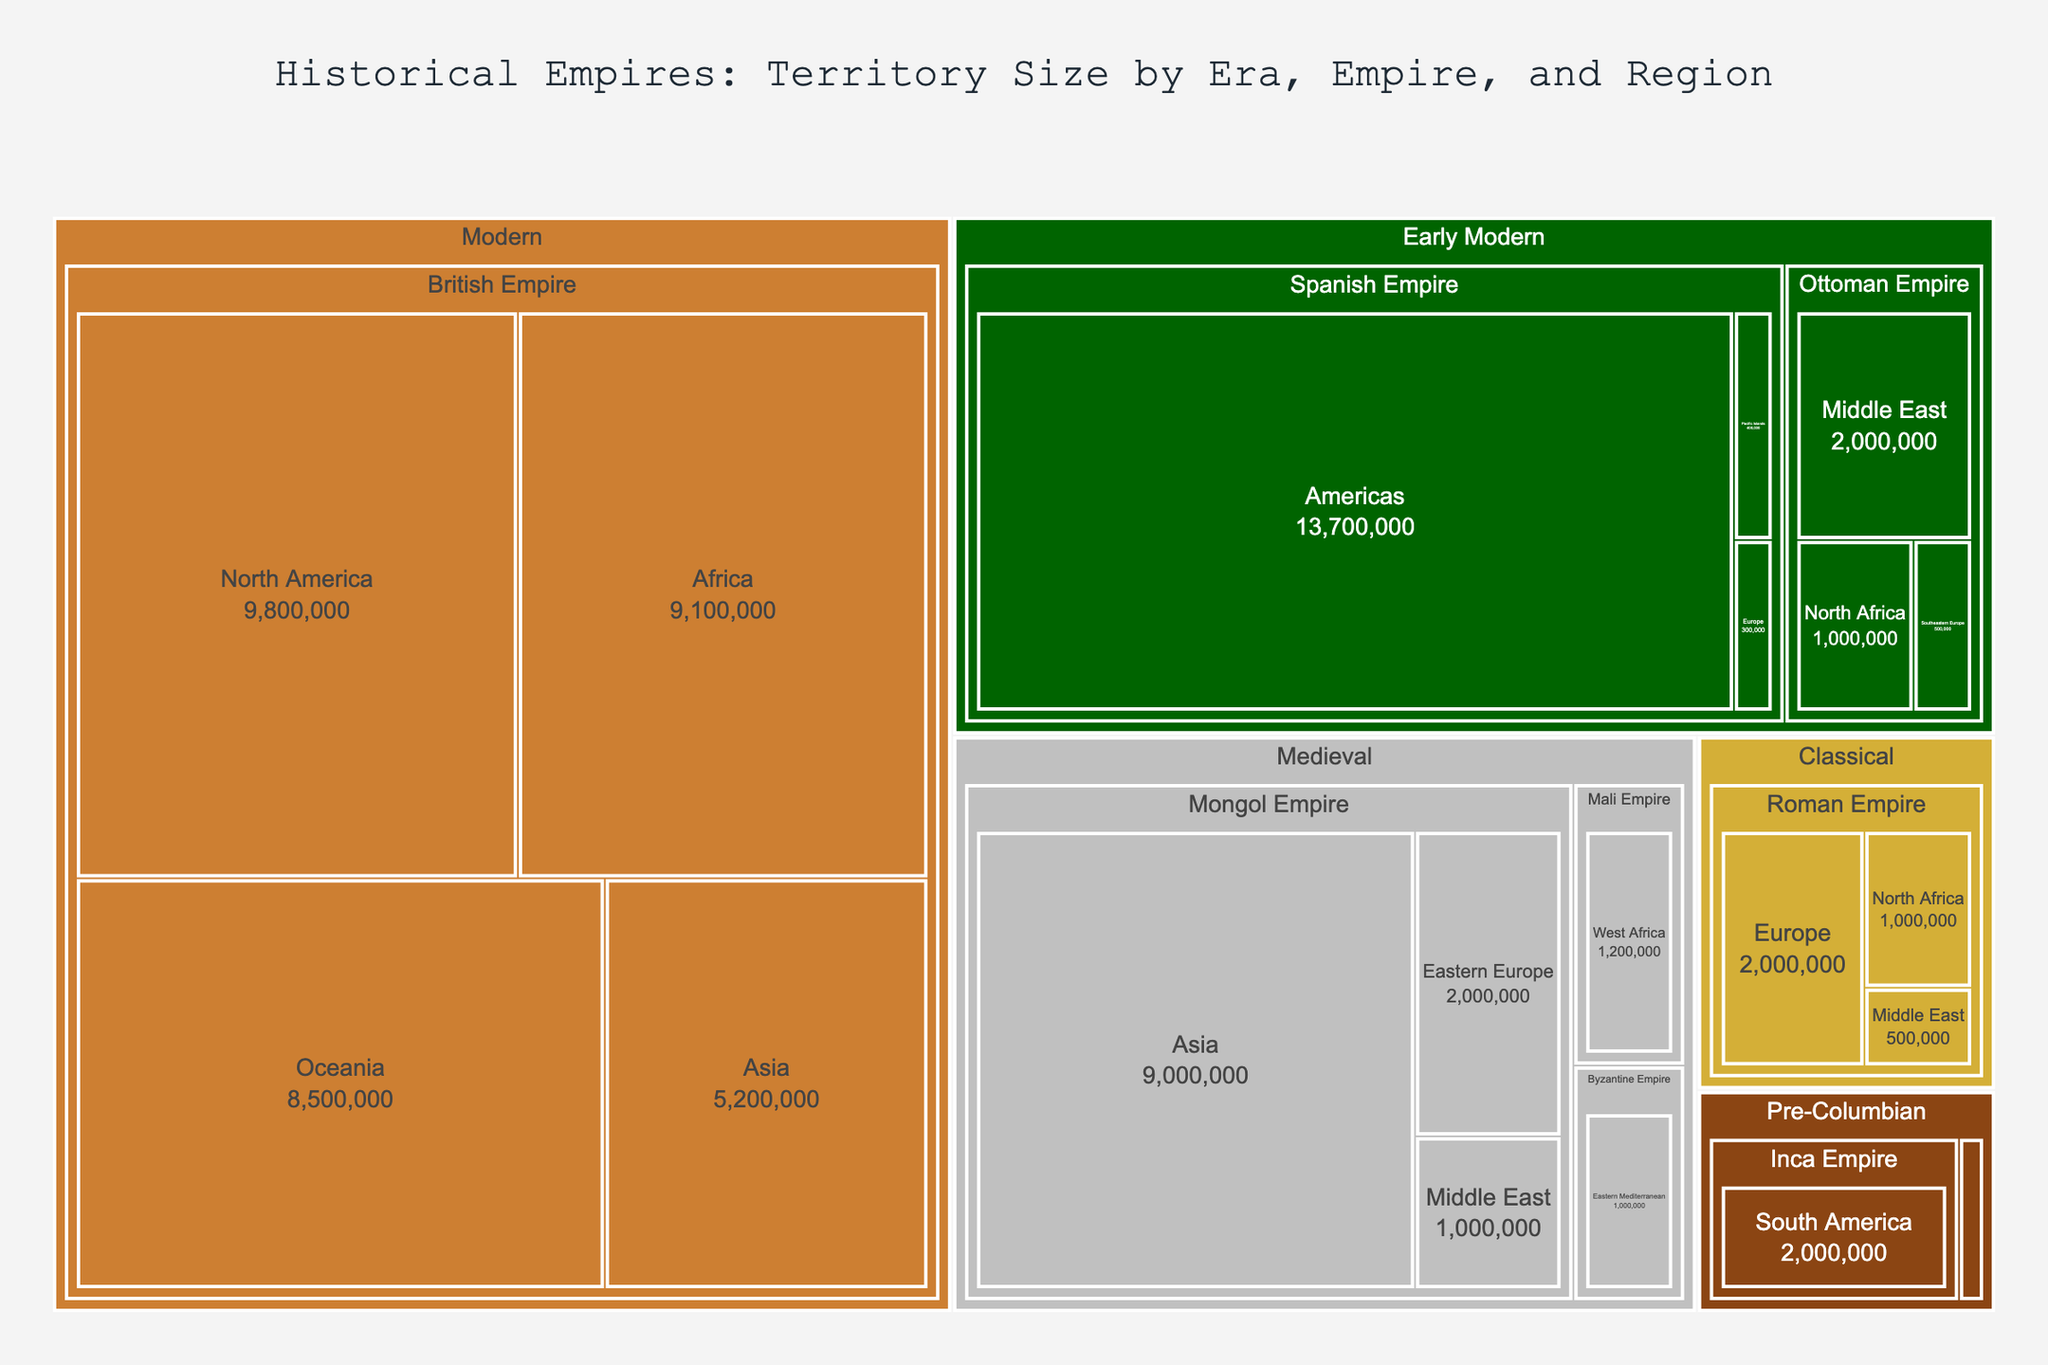What's the title of the Treemap plot? The title of the Treemap plot is usually displayed prominently at the top of the figure. In this case, it is specified in the data that the title is "Historical Empires: Territory Size by Era, Empire, and Region".
Answer: Historical Empires: Territory Size by Era, Empire, and Region Which color represents the Medieval era in the Treemap? The figure uses distinct colors for different eras. According to the data, the Medieval era is represented by the color silver.
Answer: Silver What is the total territory size of the Mongol Empire across all regions? The Mongol Empire has territory sizes of 9,000,000 (Asia), 2,000,000 (Eastern Europe), and 1,000,000 (Middle East). Adding these up, 9,000,000 + 2,000,000 + 1,000,000, results in a total of 12,000,000 sq km.
Answer: 12,000,000 sq km How does the territory size of the Inca Empire compare with that of the Aztec Empire? The Inca Empire has a territory size of 2,000,000 sq km, while the Aztec Empire has a territory size of 200,000 sq km. The Inca Empire is significantly larger.
Answer: The Inca Empire is larger Which empire had the largest territory size in the Early Modern era? The Early Modern era includes the Spanish Empire, Ottoman Empire, and part of the British Empire. The Spanish Empire's territory sizes are 13,700,000 (Americas), 400,000 (Pacific Islands), and 300,000 (Europe), totaling 14,400,000 sq km, which is the largest in the Early Modern era.
Answer: The Spanish Empire What is the combined territory size of the Roman Empire's regions? The Roman Empire's territories are listed as 2,000,000 (Europe), 1,000,000 (North Africa), and 500,000 (Middle East). Adding these together gives 2,000,000 + 1,000,000 + 500,000, totaling 3,500,000 sq km.
Answer: 3,500,000 sq km Which empires are represented in the Modern era, and what are their respective territory sizes? The Modern era includes only the British Empire, with the following territories: 9,800,000 (North America), 9,100,000 (Africa), 5,200,000 (Asia), and 8,500,000 (Oceania).
Answer: British Empire: 9,800,000 (North America), 9,100,000 (Africa), 5,200,000 (Asia), 8,500,000 (Oceania) Which region did the Byzantine Empire control, and what was its territory size? The Byzantine Empire controlled the Eastern Mediterranean region, with a territory size of 1,000,000 sq km according to the data provided.
Answer: Eastern Mediterranean, 1,000,000 sq km How does the territory size of the Mali Empire in West Africa during the Medieval era compare to the Roman Empire's territory size in North Africa during the Classical era? The Mali Empire has a territory size of 1,200,000 sq km in West Africa, while the Roman Empire has a territory size of 1,000,000 sq km in North Africa. So, the Mali Empire had a slightly larger territory size.
Answer: The Mali Empire is larger 